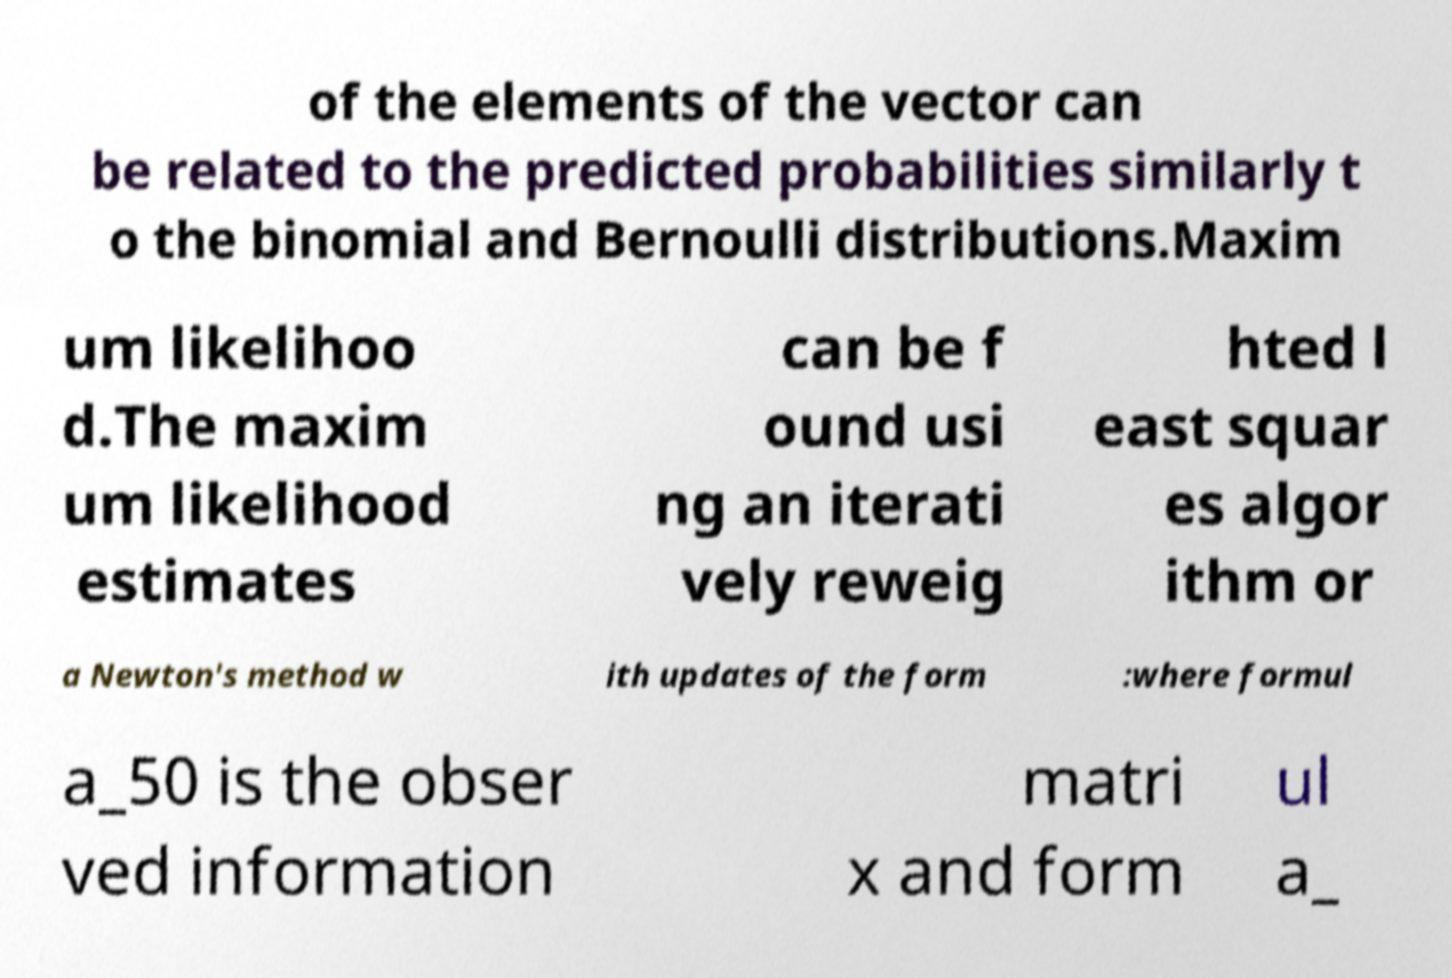I need the written content from this picture converted into text. Can you do that? of the elements of the vector can be related to the predicted probabilities similarly t o the binomial and Bernoulli distributions.Maxim um likelihoo d.The maxim um likelihood estimates can be f ound usi ng an iterati vely reweig hted l east squar es algor ithm or a Newton's method w ith updates of the form :where formul a_50 is the obser ved information matri x and form ul a_ 